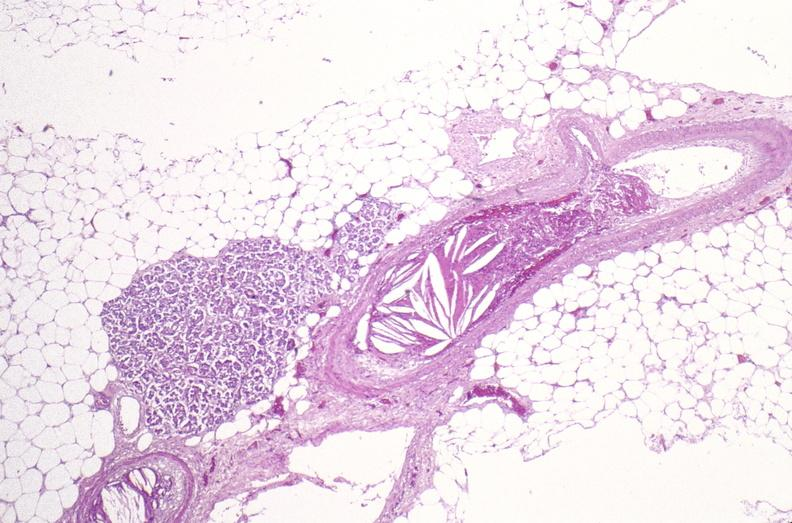s muscle present?
Answer the question using a single word or phrase. Yes 